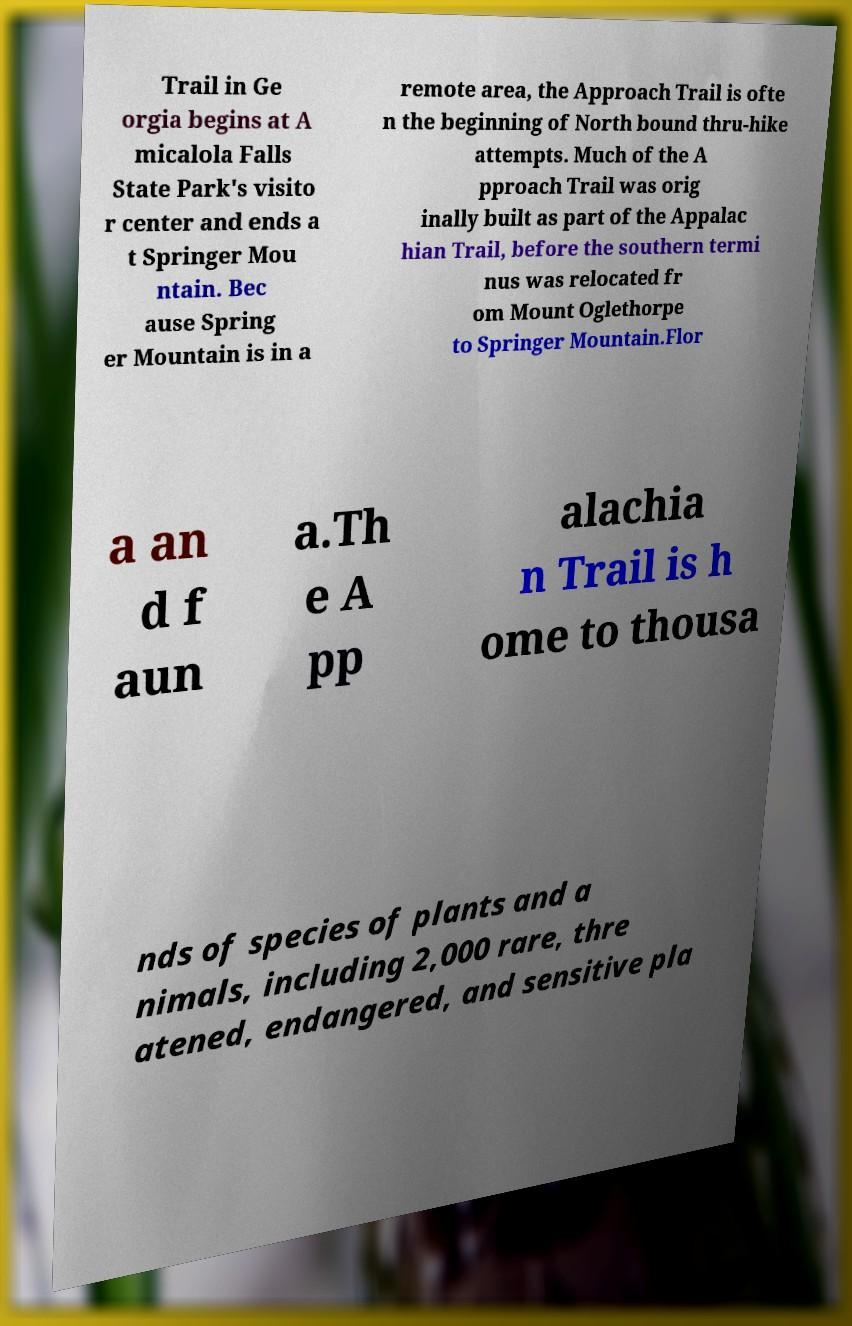Can you read and provide the text displayed in the image?This photo seems to have some interesting text. Can you extract and type it out for me? Trail in Ge orgia begins at A micalola Falls State Park's visito r center and ends a t Springer Mou ntain. Bec ause Spring er Mountain is in a remote area, the Approach Trail is ofte n the beginning of North bound thru-hike attempts. Much of the A pproach Trail was orig inally built as part of the Appalac hian Trail, before the southern termi nus was relocated fr om Mount Oglethorpe to Springer Mountain.Flor a an d f aun a.Th e A pp alachia n Trail is h ome to thousa nds of species of plants and a nimals, including 2,000 rare, thre atened, endangered, and sensitive pla 